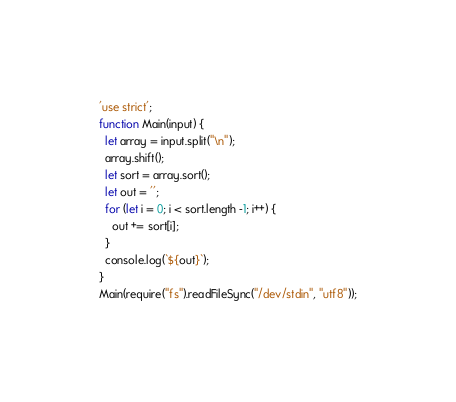<code> <loc_0><loc_0><loc_500><loc_500><_JavaScript_>'use strict';
function Main(input) {
  let array = input.split("\n");
  array.shift();
  let sort = array.sort();
  let out = '';
  for (let i = 0; i < sort.length -1; i++) {
    out += sort[i];
  }
  console.log(`${out}`);
}
Main(require("fs").readFileSync("/dev/stdin", "utf8"));</code> 